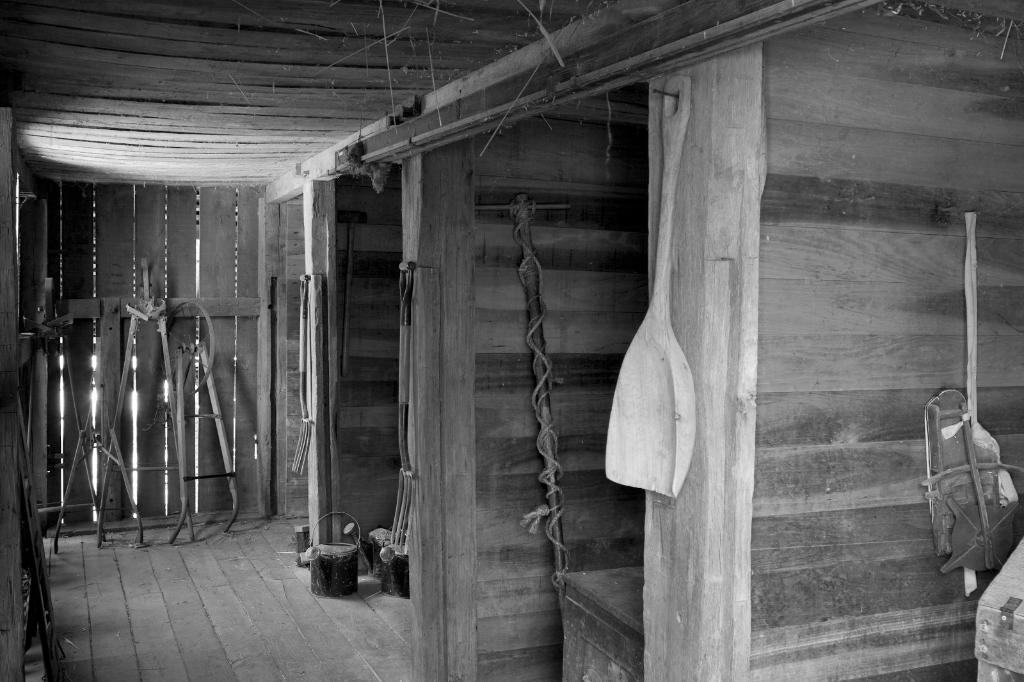Can you describe this image briefly? In this picture we can see a spoon, rods, wooden planks and some objects and in the background we can see a wall, roof. 